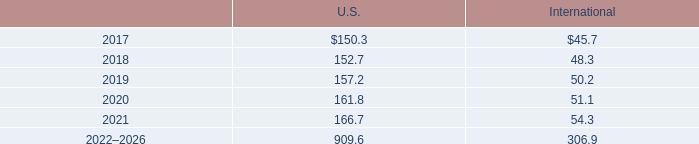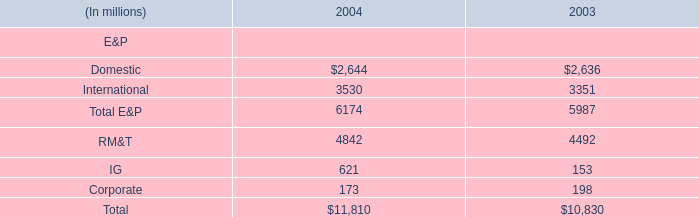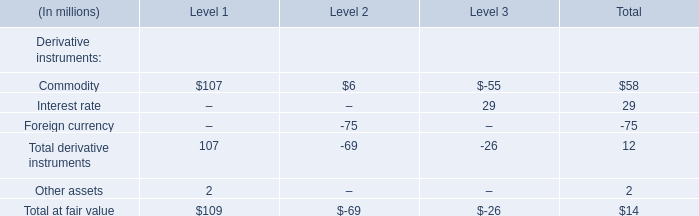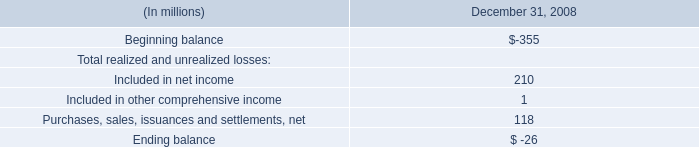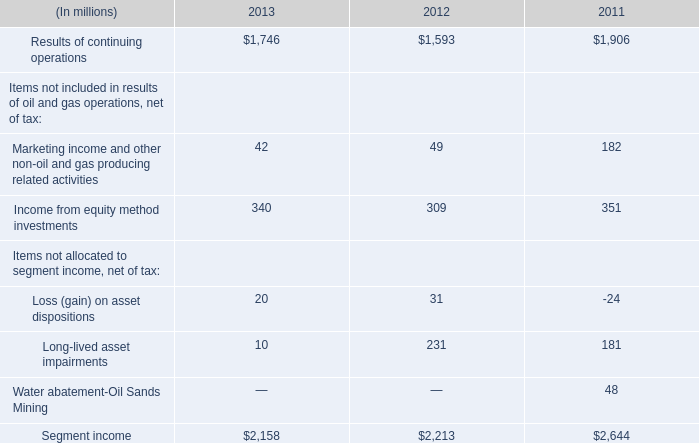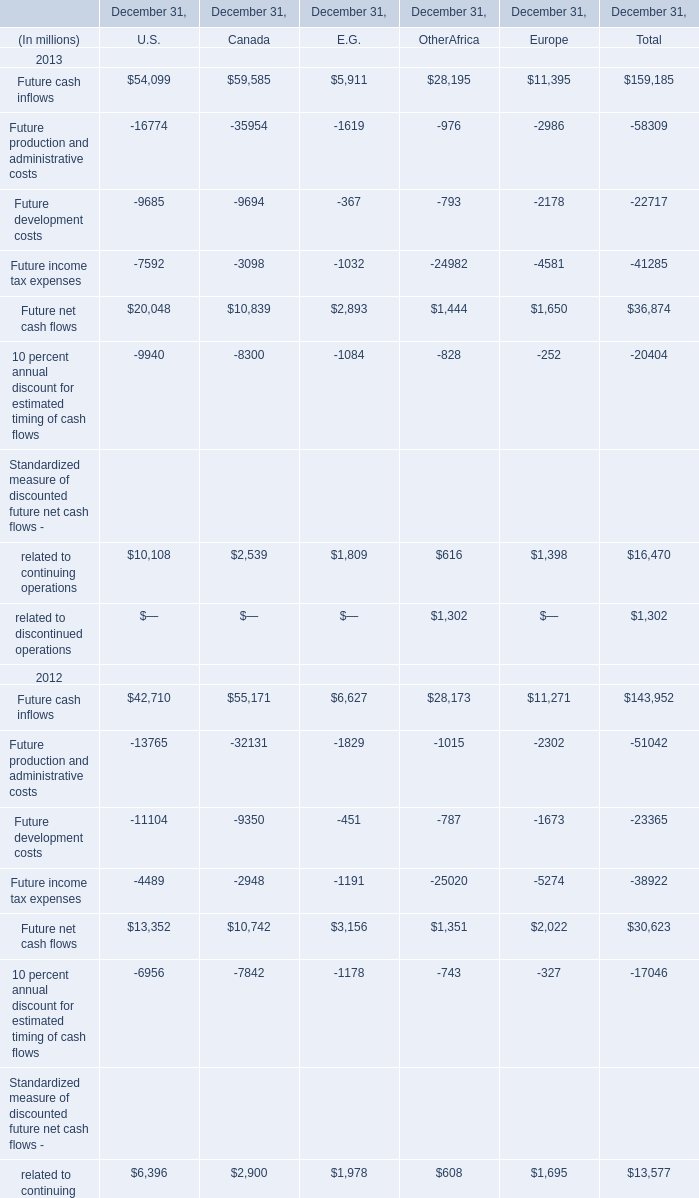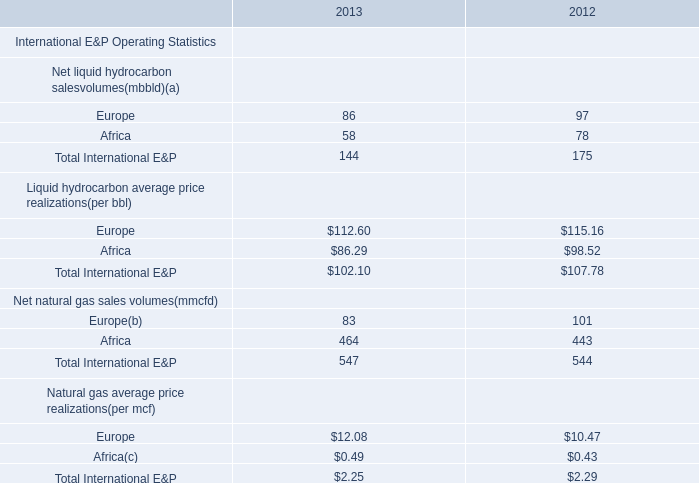What is the sum of Results of continuing operations of 2011, and Future net cash flows of December 31, Europe ? 
Computations: (1906.0 + 1650.0)
Answer: 3556.0. 